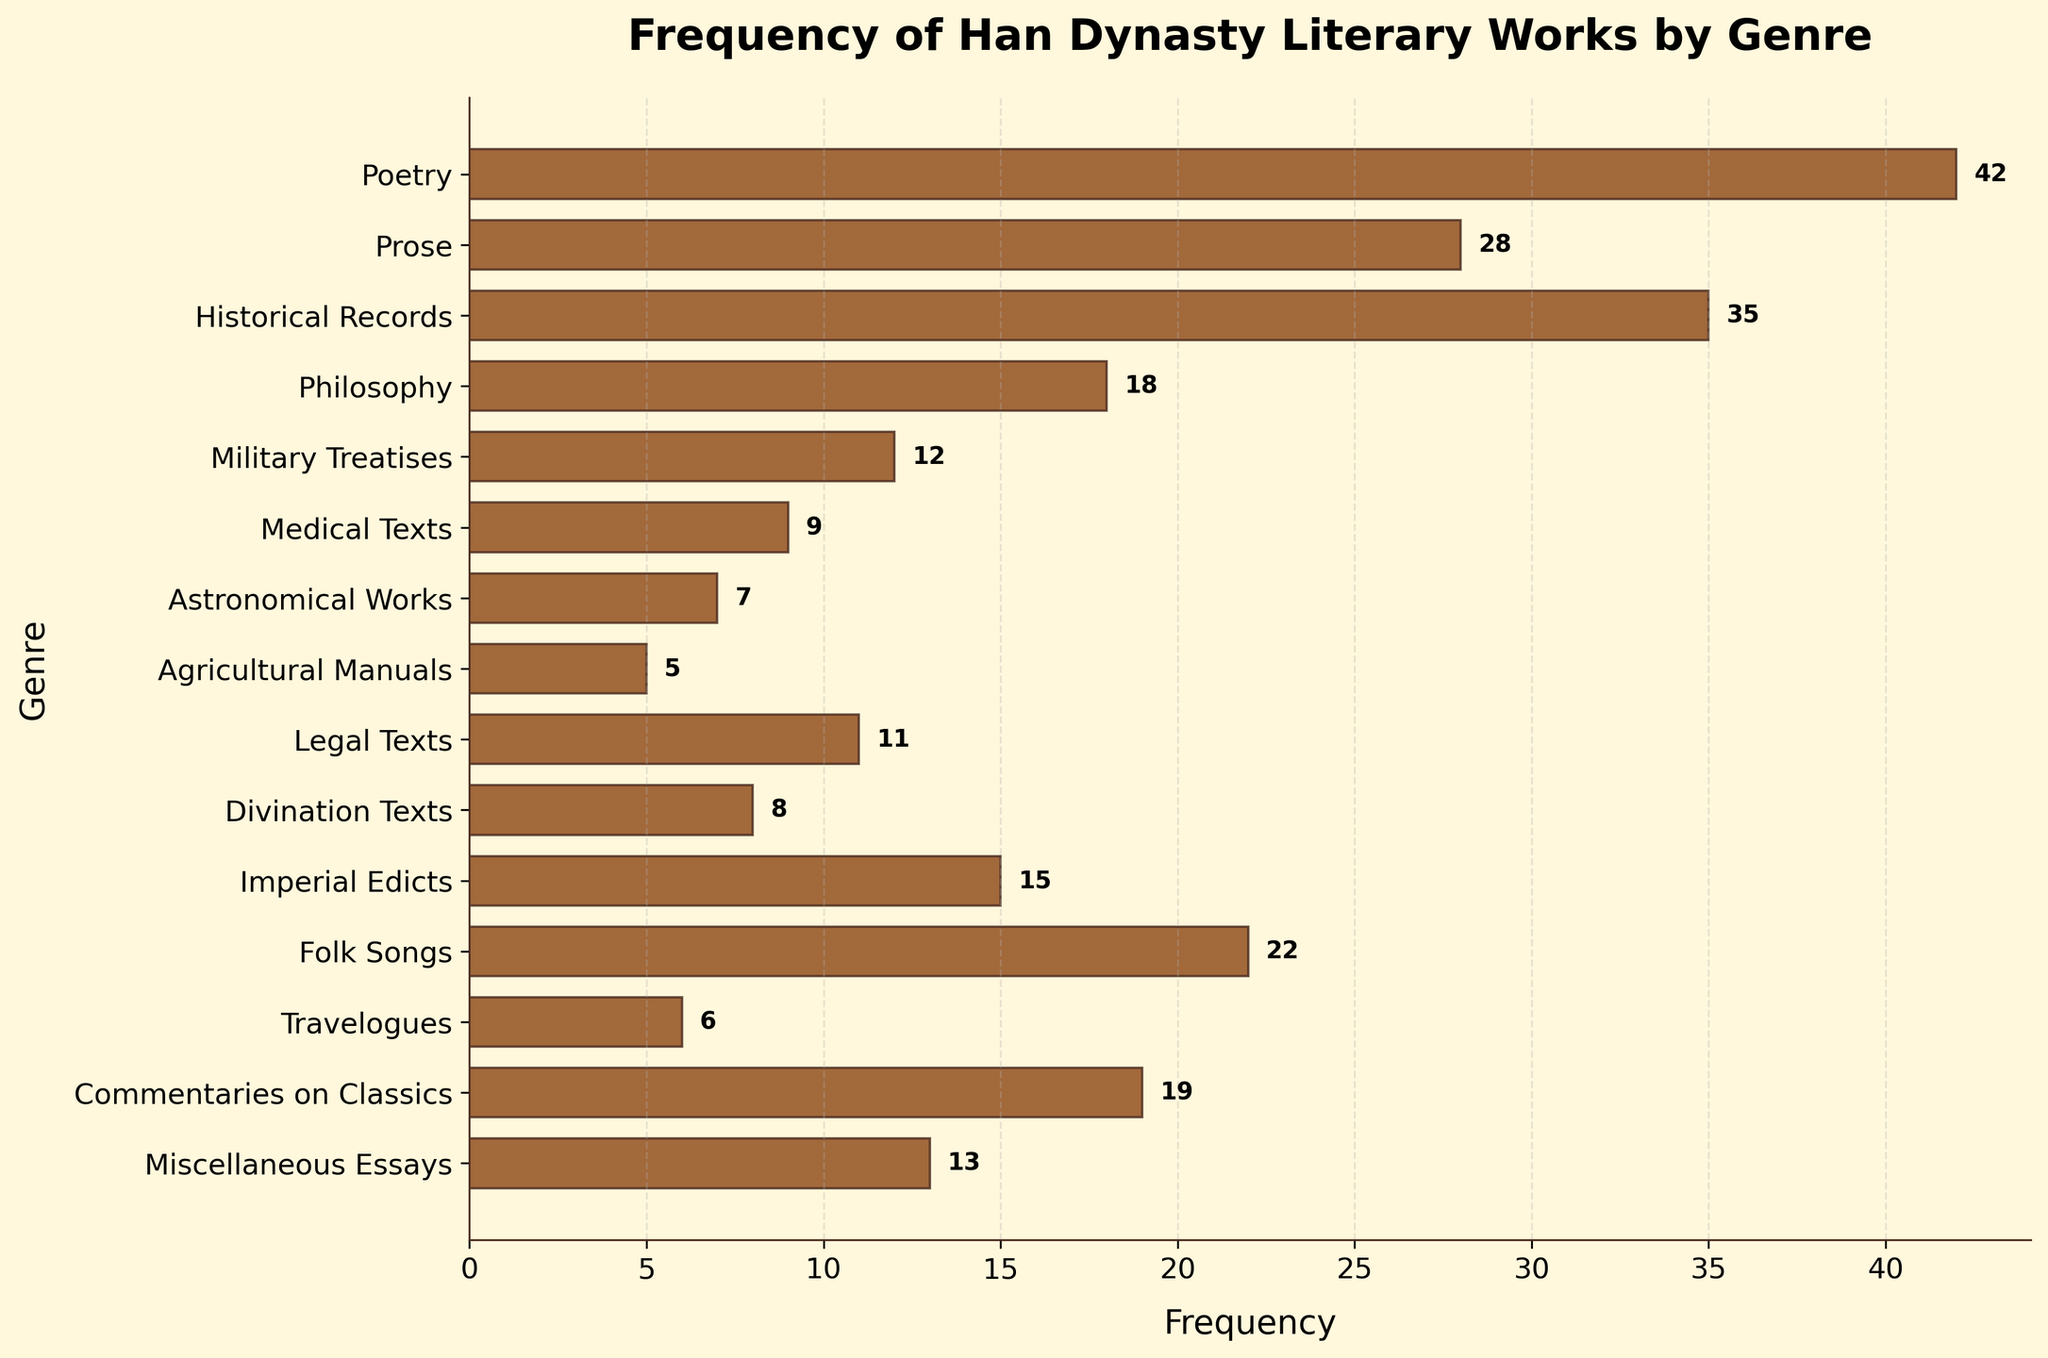Which genre has the highest frequency of literary works in the Han dynasty? The bar at the top of the plot represents Poetry, and it is the longest bar, indicating it has the highest frequency.
Answer: Poetry What is the frequency of Travelogues? The bar representing Travelogues has a small label next to it stating the frequency value.
Answer: 6 Which genre has a higher frequency: Military Treatises or Legal Texts? By comparing the length of the bars for Military Treatises and Legal Texts, the bar for Legal Texts is longer.
Answer: Legal Texts What is the total frequency of works in Philosophy, Medical Texts, and Travelogues combined? Sum the individual frequencies: Philosophy (18), Medical Texts (9), and Travelogues (6). The total is 18 + 9 + 6.
Answer: 33 Are Commentaries on Classics more frequent than Miscellaneous Essays? By comparing the bars, Commentaries on Classics has a slightly longer bar than Miscellaneous Essays.
Answer: Yes Which genre has the shortest bar in the plot? The bar for the Agricultural Manuals is the shortest as it is at the bottom with the smallest value.
Answer: Agricultural Manuals How does the frequency of Folk Songs compare to Prose? The bar for Folk Songs (22) is shorter than that for Prose (28).
Answer: Folk Songs are less frequent than Prose What is the sum of the frequencies of the top three most frequent genres? Sum the frequencies of the top three genres: Poetry (42), Historical Records (35), and Prose (28). The total is 42 + 35 + 28.
Answer: 105 How does the frequency of Imperial Edicts compare to Divination Texts? Compare the lengths of the respective bars; Imperial Edicts (15) is longer than Divination Texts (8).
Answer: Imperial Edicts are more frequent than Divination Texts What is the average frequency of all the genres listed? Sum all frequencies: 42 + 28 + 35 + 18 + 12 + 9 + 7 + 5 + 11 + 8 + 15 + 22 + 6 + 19 + 13 = 250. Divide by the number of genres (15). 250 / 15.
Answer: 16.7 